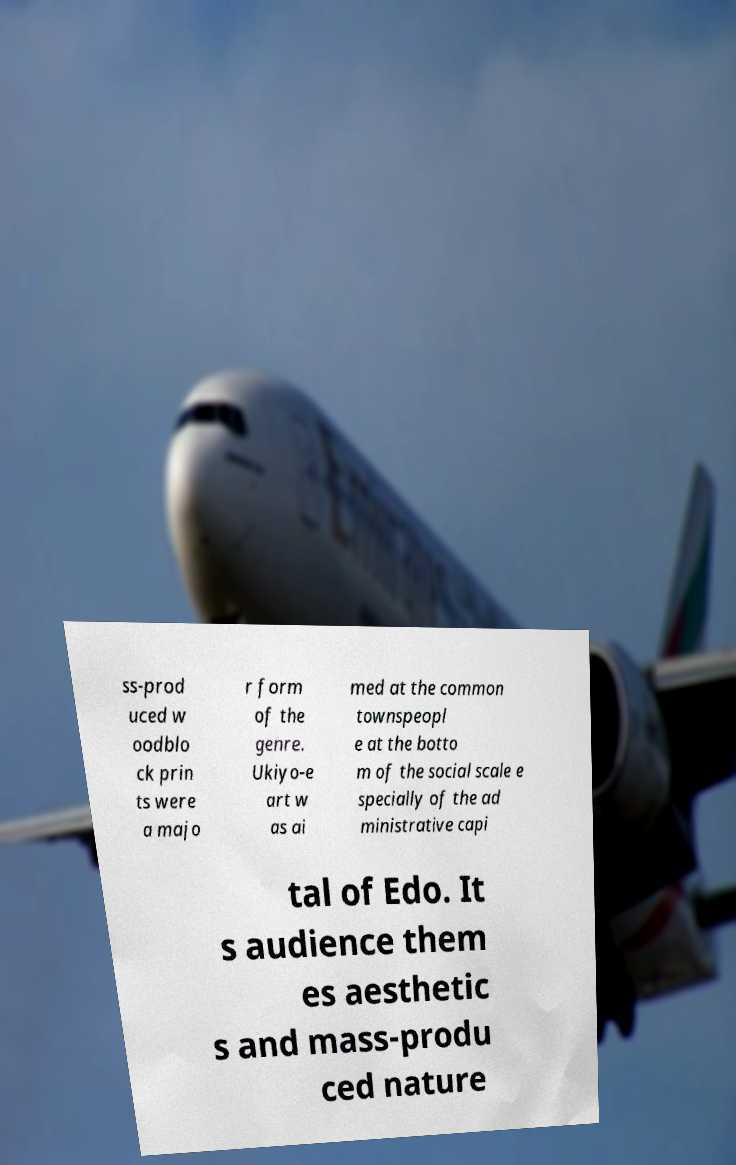What messages or text are displayed in this image? I need them in a readable, typed format. ss-prod uced w oodblo ck prin ts were a majo r form of the genre. Ukiyo-e art w as ai med at the common townspeopl e at the botto m of the social scale e specially of the ad ministrative capi tal of Edo. It s audience them es aesthetic s and mass-produ ced nature 